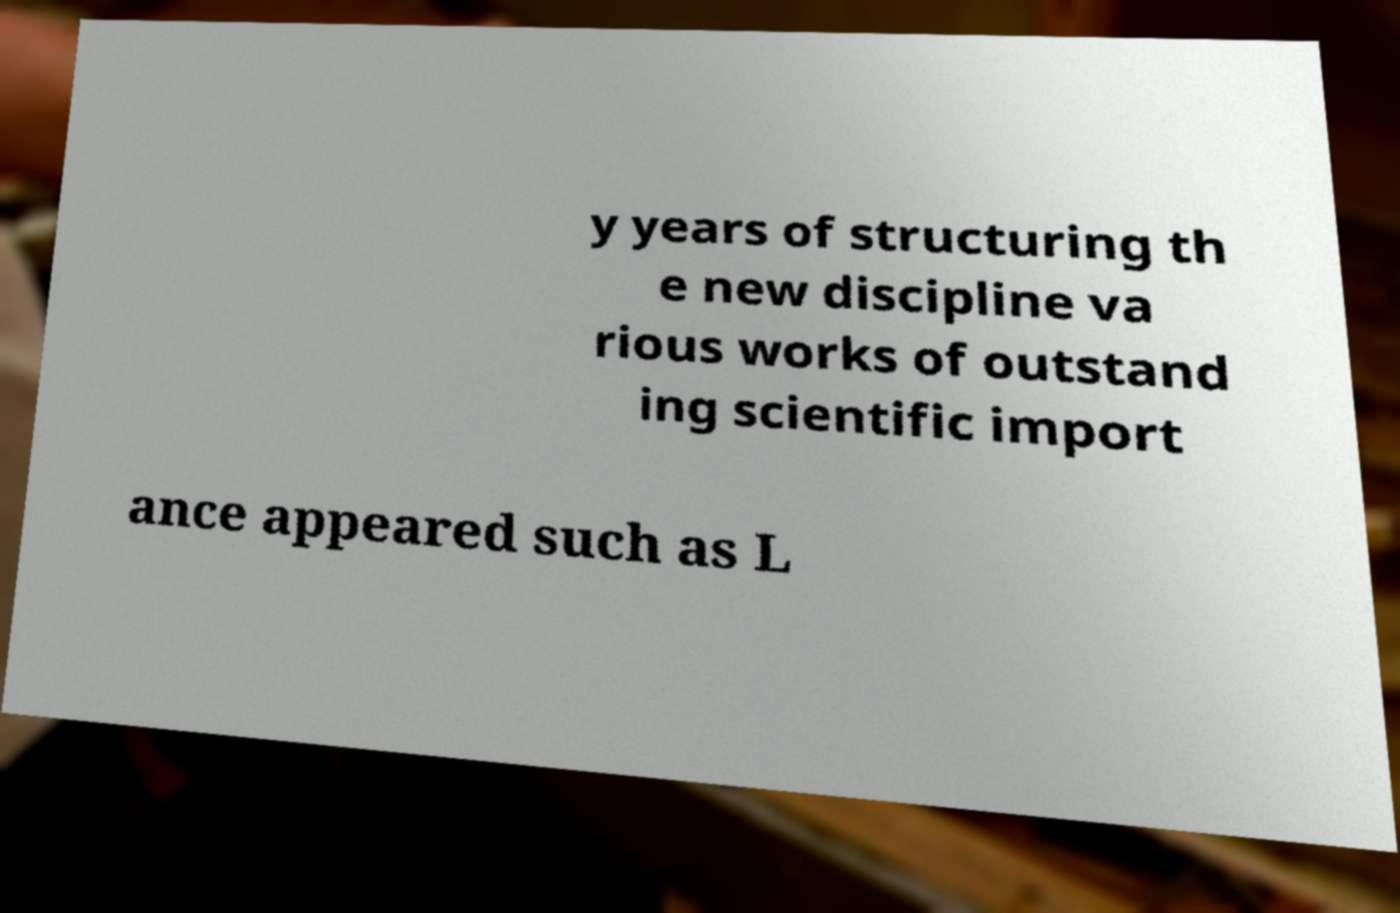For documentation purposes, I need the text within this image transcribed. Could you provide that? y years of structuring th e new discipline va rious works of outstand ing scientific import ance appeared such as L 